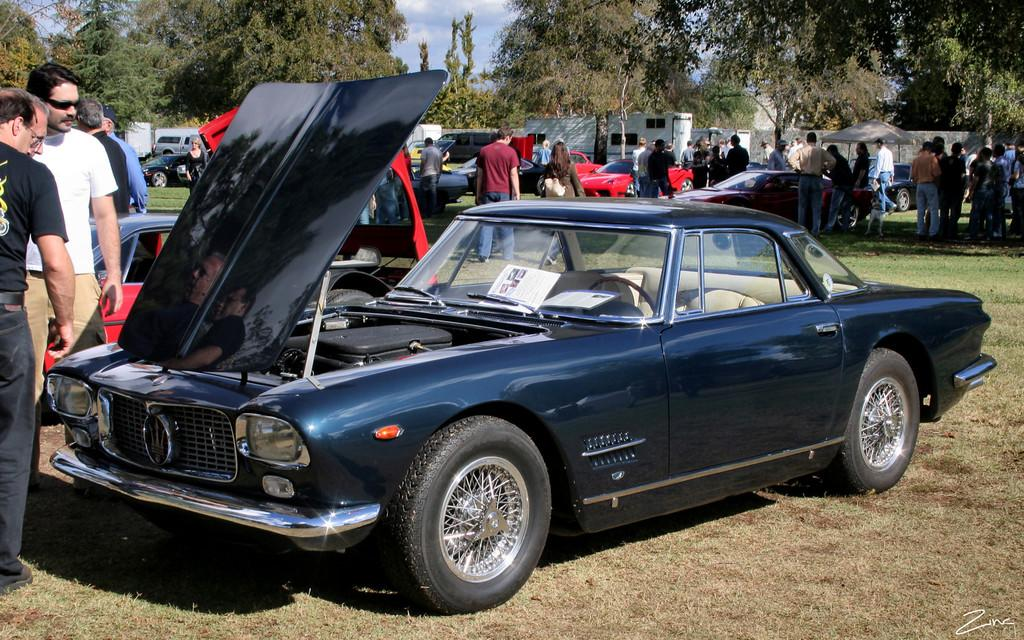What can be seen in the foreground of the picture? In the foreground of the picture, there are cars, people, and grass. What else is present in the middle of the picture? In the middle of the picture, there are cars, vehicles, people, and trees. Can you describe the background of the picture? In the background of the picture, there are trees and sky visible. How many robins are perched on the trees in the picture? There are no robins present in the picture; only cars, people, grass, trees, and sky are visible. Are there any horses visible in the picture? There are no horses present in the picture. 